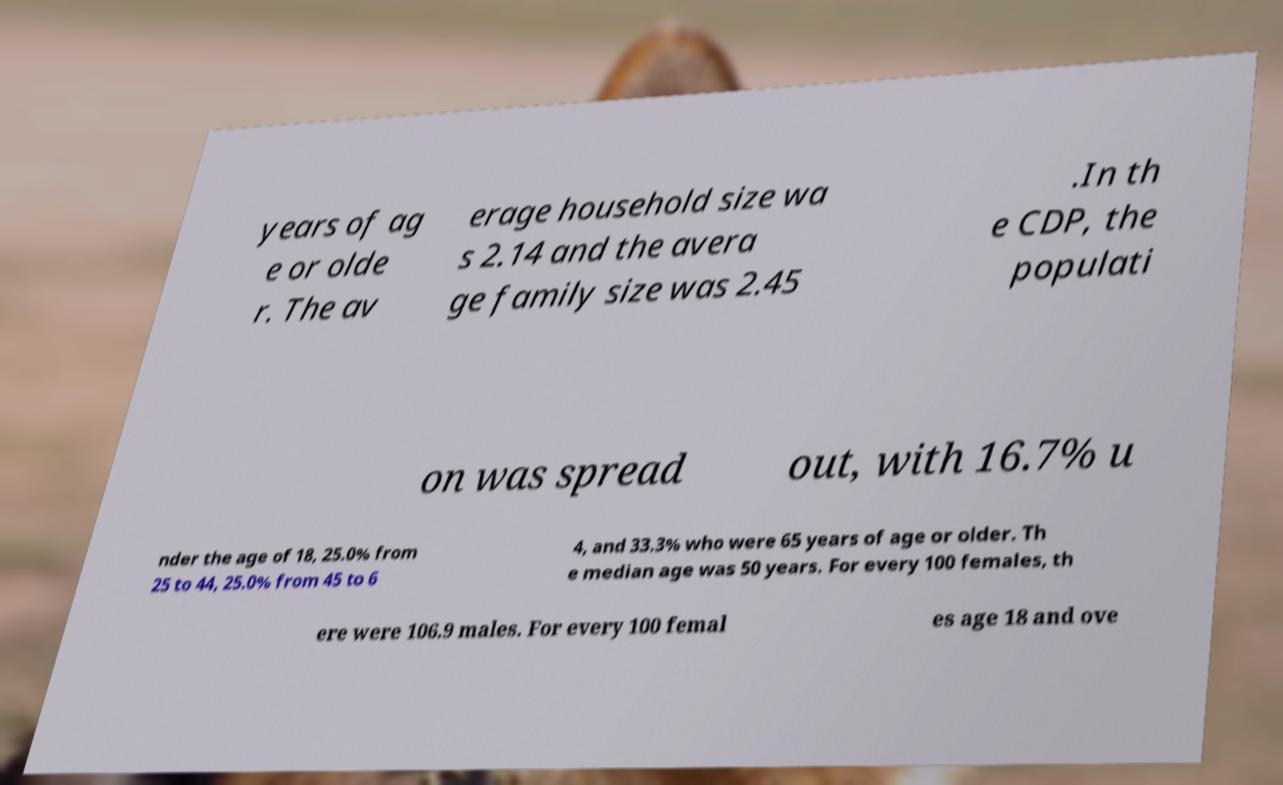For documentation purposes, I need the text within this image transcribed. Could you provide that? years of ag e or olde r. The av erage household size wa s 2.14 and the avera ge family size was 2.45 .In th e CDP, the populati on was spread out, with 16.7% u nder the age of 18, 25.0% from 25 to 44, 25.0% from 45 to 6 4, and 33.3% who were 65 years of age or older. Th e median age was 50 years. For every 100 females, th ere were 106.9 males. For every 100 femal es age 18 and ove 